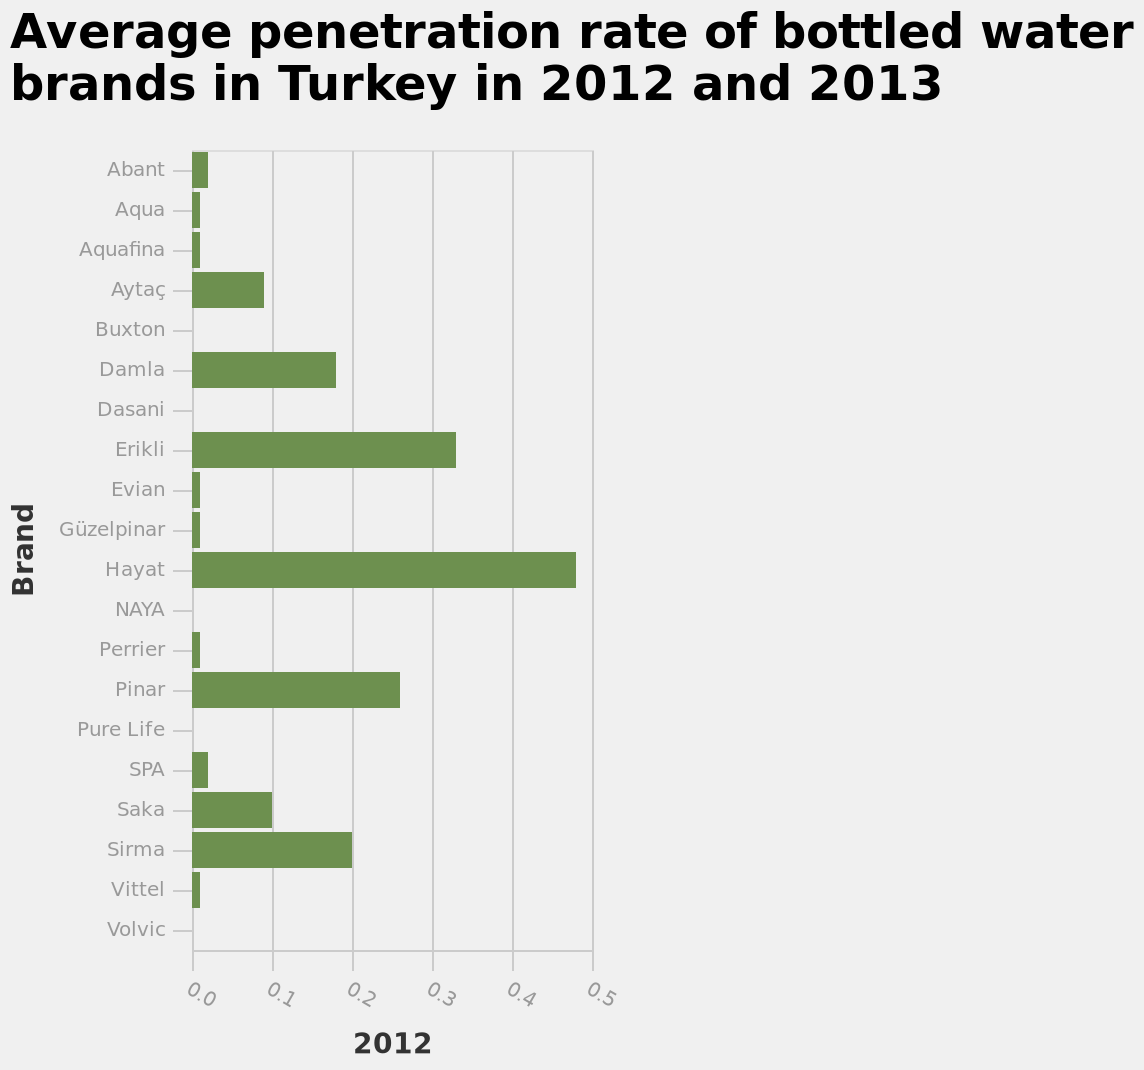<image>
Which water brand ranked last in popularity in Turkey in 2012? Buxton. What years are represented in the bar plot? The bar plot represents data from 2012 and 2013. What is the title of the bar plot?  The title of the bar plot is "Average penetration rate of bottled water brands in Turkey in 2012 and 2013". What is the range of the y-axis brands? The y-axis brands range from "Abant" to "Volvic". 